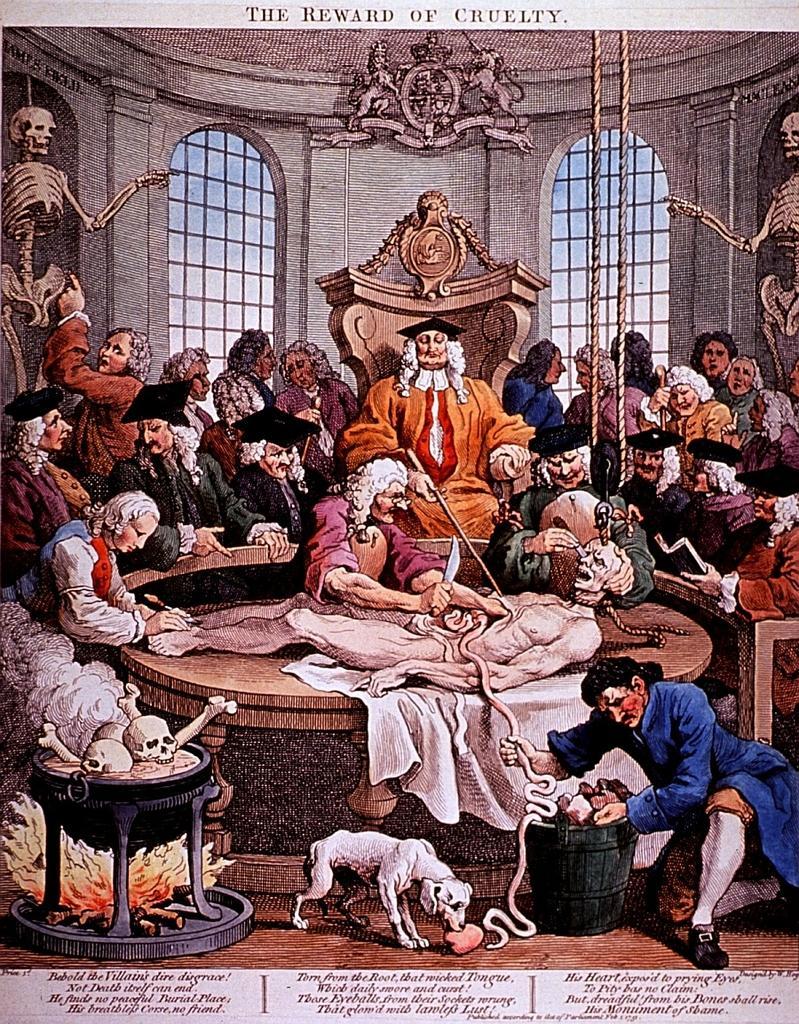How would you summarize this image in a sentence or two? In this image, It looks like a painting. I can see groups of people sitting and a person lying. At the bottom of the image, I can see a dog standing. On the left side of the image, It is a kind of a stove with a bowl of skulls and bones in it. On the left and right side of the image, I can see skeletons. At the top of the image, these are the sculptures. At the bottom and top of the image, I can see the letters. 